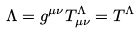Convert formula to latex. <formula><loc_0><loc_0><loc_500><loc_500>\Lambda = g ^ { \mu \nu } T ^ { \Lambda } _ { \mu \nu } = T ^ { \Lambda }</formula> 